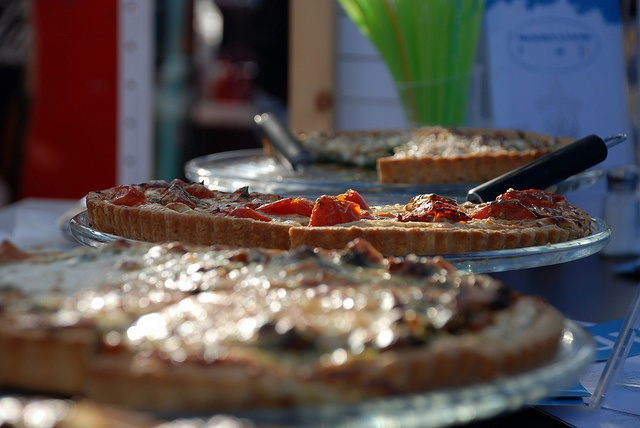Describe the objects in this image and their specific colors. I can see pizza in black, maroon, gray, and darkgray tones, pizza in black, maroon, and gray tones, and pizza in black, gray, and maroon tones in this image. 